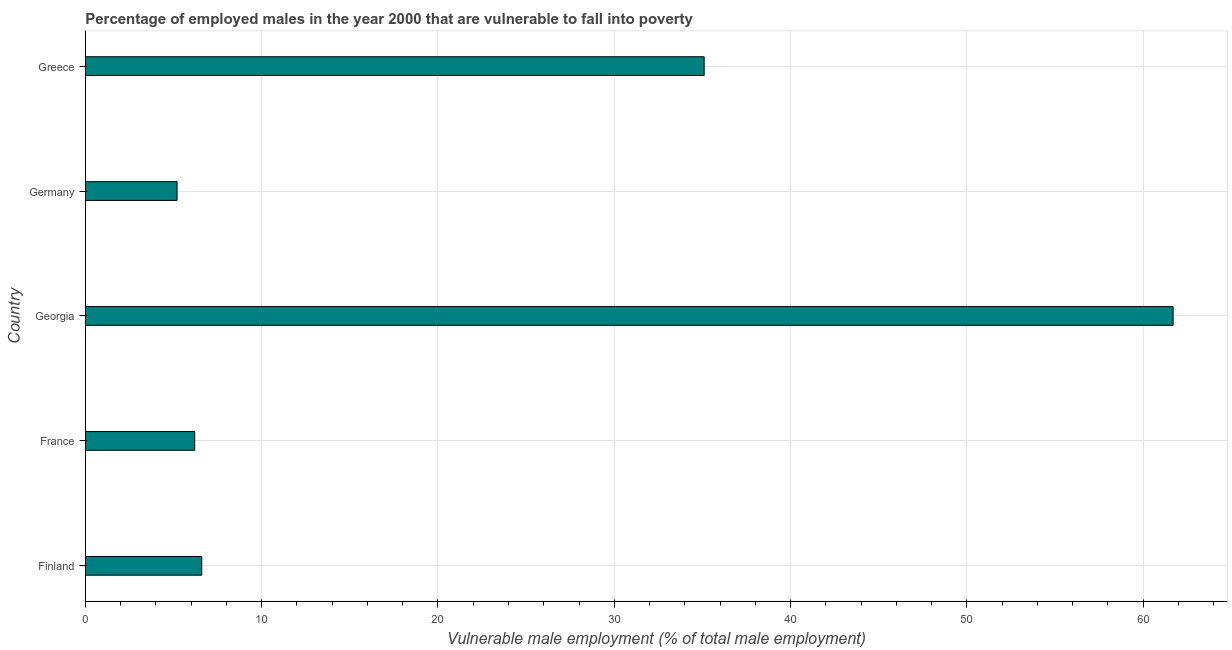Does the graph contain any zero values?
Make the answer very short. No. Does the graph contain grids?
Offer a very short reply. Yes. What is the title of the graph?
Provide a short and direct response. Percentage of employed males in the year 2000 that are vulnerable to fall into poverty. What is the label or title of the X-axis?
Offer a terse response. Vulnerable male employment (% of total male employment). What is the percentage of employed males who are vulnerable to fall into poverty in Georgia?
Provide a short and direct response. 61.7. Across all countries, what is the maximum percentage of employed males who are vulnerable to fall into poverty?
Your answer should be very brief. 61.7. Across all countries, what is the minimum percentage of employed males who are vulnerable to fall into poverty?
Offer a very short reply. 5.2. In which country was the percentage of employed males who are vulnerable to fall into poverty maximum?
Give a very brief answer. Georgia. In which country was the percentage of employed males who are vulnerable to fall into poverty minimum?
Your answer should be compact. Germany. What is the sum of the percentage of employed males who are vulnerable to fall into poverty?
Your answer should be compact. 114.8. What is the difference between the percentage of employed males who are vulnerable to fall into poverty in France and Greece?
Offer a terse response. -28.9. What is the average percentage of employed males who are vulnerable to fall into poverty per country?
Keep it short and to the point. 22.96. What is the median percentage of employed males who are vulnerable to fall into poverty?
Offer a terse response. 6.6. What is the ratio of the percentage of employed males who are vulnerable to fall into poverty in Finland to that in Germany?
Provide a succinct answer. 1.27. Is the difference between the percentage of employed males who are vulnerable to fall into poverty in Germany and Greece greater than the difference between any two countries?
Offer a terse response. No. What is the difference between the highest and the second highest percentage of employed males who are vulnerable to fall into poverty?
Make the answer very short. 26.6. Is the sum of the percentage of employed males who are vulnerable to fall into poverty in Georgia and Greece greater than the maximum percentage of employed males who are vulnerable to fall into poverty across all countries?
Keep it short and to the point. Yes. What is the difference between the highest and the lowest percentage of employed males who are vulnerable to fall into poverty?
Provide a succinct answer. 56.5. Are all the bars in the graph horizontal?
Your answer should be very brief. Yes. How many countries are there in the graph?
Ensure brevity in your answer.  5. Are the values on the major ticks of X-axis written in scientific E-notation?
Offer a terse response. No. What is the Vulnerable male employment (% of total male employment) in Finland?
Your answer should be compact. 6.6. What is the Vulnerable male employment (% of total male employment) in France?
Your answer should be compact. 6.2. What is the Vulnerable male employment (% of total male employment) in Georgia?
Your answer should be very brief. 61.7. What is the Vulnerable male employment (% of total male employment) of Germany?
Make the answer very short. 5.2. What is the Vulnerable male employment (% of total male employment) of Greece?
Provide a short and direct response. 35.1. What is the difference between the Vulnerable male employment (% of total male employment) in Finland and France?
Provide a short and direct response. 0.4. What is the difference between the Vulnerable male employment (% of total male employment) in Finland and Georgia?
Your answer should be compact. -55.1. What is the difference between the Vulnerable male employment (% of total male employment) in Finland and Germany?
Make the answer very short. 1.4. What is the difference between the Vulnerable male employment (% of total male employment) in Finland and Greece?
Give a very brief answer. -28.5. What is the difference between the Vulnerable male employment (% of total male employment) in France and Georgia?
Your answer should be very brief. -55.5. What is the difference between the Vulnerable male employment (% of total male employment) in France and Greece?
Make the answer very short. -28.9. What is the difference between the Vulnerable male employment (% of total male employment) in Georgia and Germany?
Keep it short and to the point. 56.5. What is the difference between the Vulnerable male employment (% of total male employment) in Georgia and Greece?
Provide a short and direct response. 26.6. What is the difference between the Vulnerable male employment (% of total male employment) in Germany and Greece?
Make the answer very short. -29.9. What is the ratio of the Vulnerable male employment (% of total male employment) in Finland to that in France?
Provide a succinct answer. 1.06. What is the ratio of the Vulnerable male employment (% of total male employment) in Finland to that in Georgia?
Your answer should be very brief. 0.11. What is the ratio of the Vulnerable male employment (% of total male employment) in Finland to that in Germany?
Ensure brevity in your answer.  1.27. What is the ratio of the Vulnerable male employment (% of total male employment) in Finland to that in Greece?
Your answer should be very brief. 0.19. What is the ratio of the Vulnerable male employment (% of total male employment) in France to that in Germany?
Provide a succinct answer. 1.19. What is the ratio of the Vulnerable male employment (% of total male employment) in France to that in Greece?
Give a very brief answer. 0.18. What is the ratio of the Vulnerable male employment (% of total male employment) in Georgia to that in Germany?
Ensure brevity in your answer.  11.87. What is the ratio of the Vulnerable male employment (% of total male employment) in Georgia to that in Greece?
Offer a very short reply. 1.76. What is the ratio of the Vulnerable male employment (% of total male employment) in Germany to that in Greece?
Give a very brief answer. 0.15. 